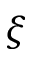<formula> <loc_0><loc_0><loc_500><loc_500>\xi</formula> 